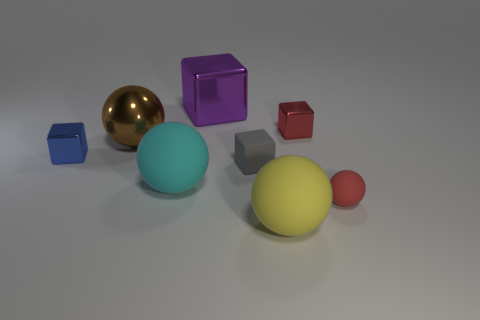Does the brown metallic sphere have the same size as the cyan matte sphere?
Offer a terse response. Yes. The tiny matte block is what color?
Your answer should be very brief. Gray. What number of objects are gray rubber objects or tiny brown matte blocks?
Make the answer very short. 1. Is there another tiny gray thing of the same shape as the gray object?
Your answer should be very brief. No. There is a cube that is on the left side of the big block; is it the same color as the large block?
Ensure brevity in your answer.  No. The tiny shiny thing behind the tiny object on the left side of the big cyan sphere is what shape?
Offer a terse response. Cube. Are there any shiny things of the same size as the gray cube?
Your answer should be very brief. Yes. Is the number of small cyan metal blocks less than the number of balls?
Make the answer very short. Yes. What is the shape of the red thing behind the rubber sphere that is right of the large matte sphere that is in front of the red rubber thing?
Ensure brevity in your answer.  Cube. How many objects are shiny cubes left of the big cyan matte object or big things that are behind the small red shiny thing?
Make the answer very short. 2. 